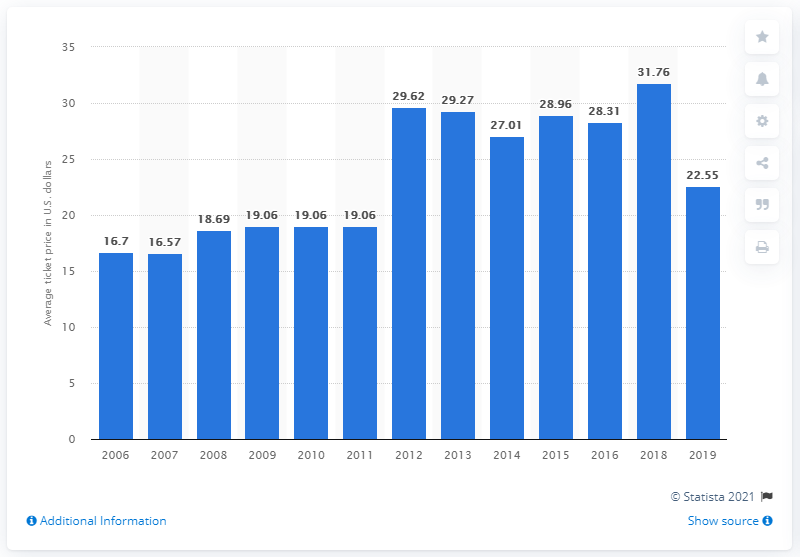Draw attention to some important aspects in this diagram. The average ticket price for Marlins games in 2019 was $22.55. 